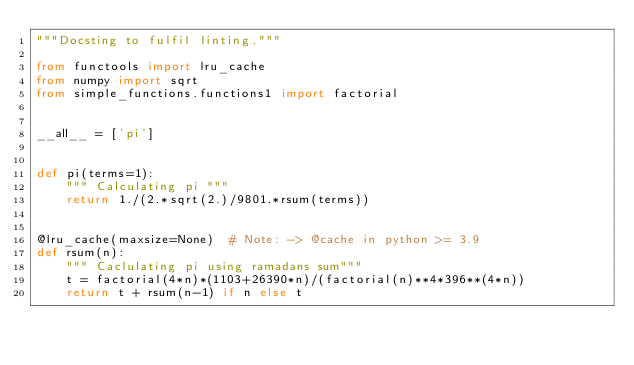<code> <loc_0><loc_0><loc_500><loc_500><_Python_>"""Docsting to fulfil linting."""

from functools import lru_cache
from numpy import sqrt
from simple_functions.functions1 import factorial


__all__ = ['pi']


def pi(terms=1):
    """ Calculating pi """
    return 1./(2.*sqrt(2.)/9801.*rsum(terms))


@lru_cache(maxsize=None)  # Note: -> @cache in python >= 3.9
def rsum(n):
    """ Caclulating pi using ramadans sum"""
    t = factorial(4*n)*(1103+26390*n)/(factorial(n)**4*396**(4*n))
    return t + rsum(n-1) if n else t
</code> 